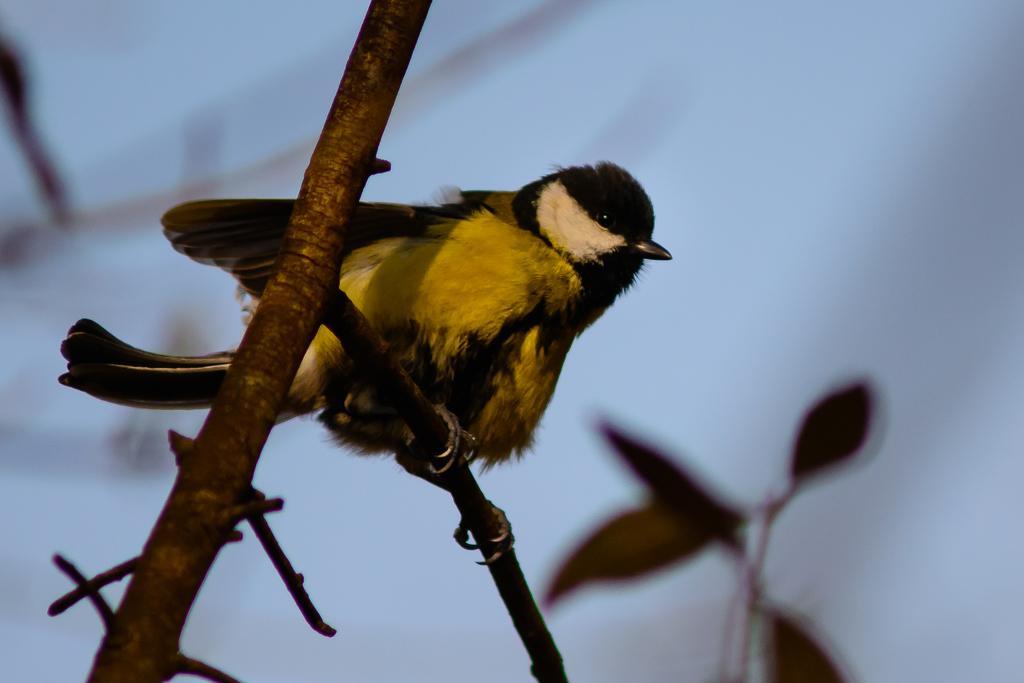Describe this image in one or two sentences. In the center of the image, we can see a bird on the stem stock and in the background, there is sky. 